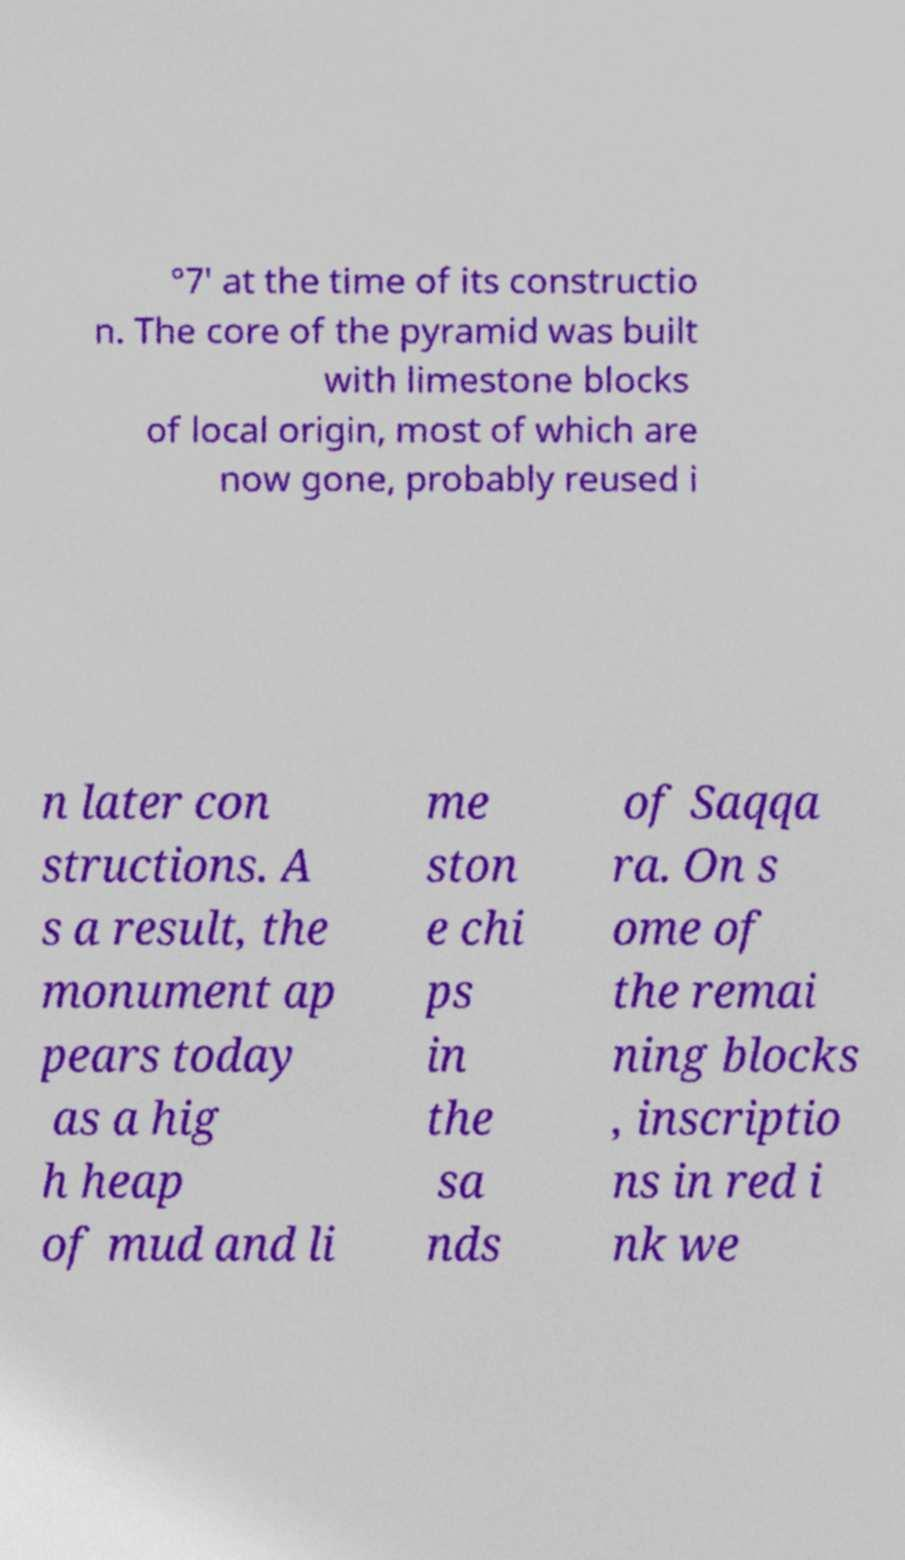There's text embedded in this image that I need extracted. Can you transcribe it verbatim? °7′ at the time of its constructio n. The core of the pyramid was built with limestone blocks of local origin, most of which are now gone, probably reused i n later con structions. A s a result, the monument ap pears today as a hig h heap of mud and li me ston e chi ps in the sa nds of Saqqa ra. On s ome of the remai ning blocks , inscriptio ns in red i nk we 